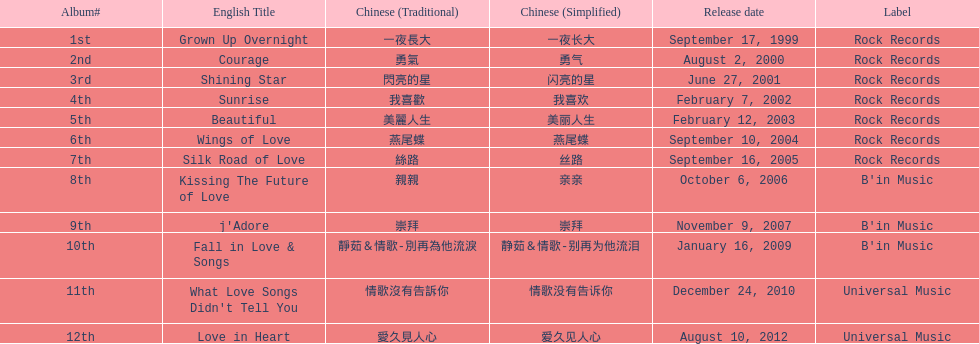What is the number of songs on rock records? 7. 